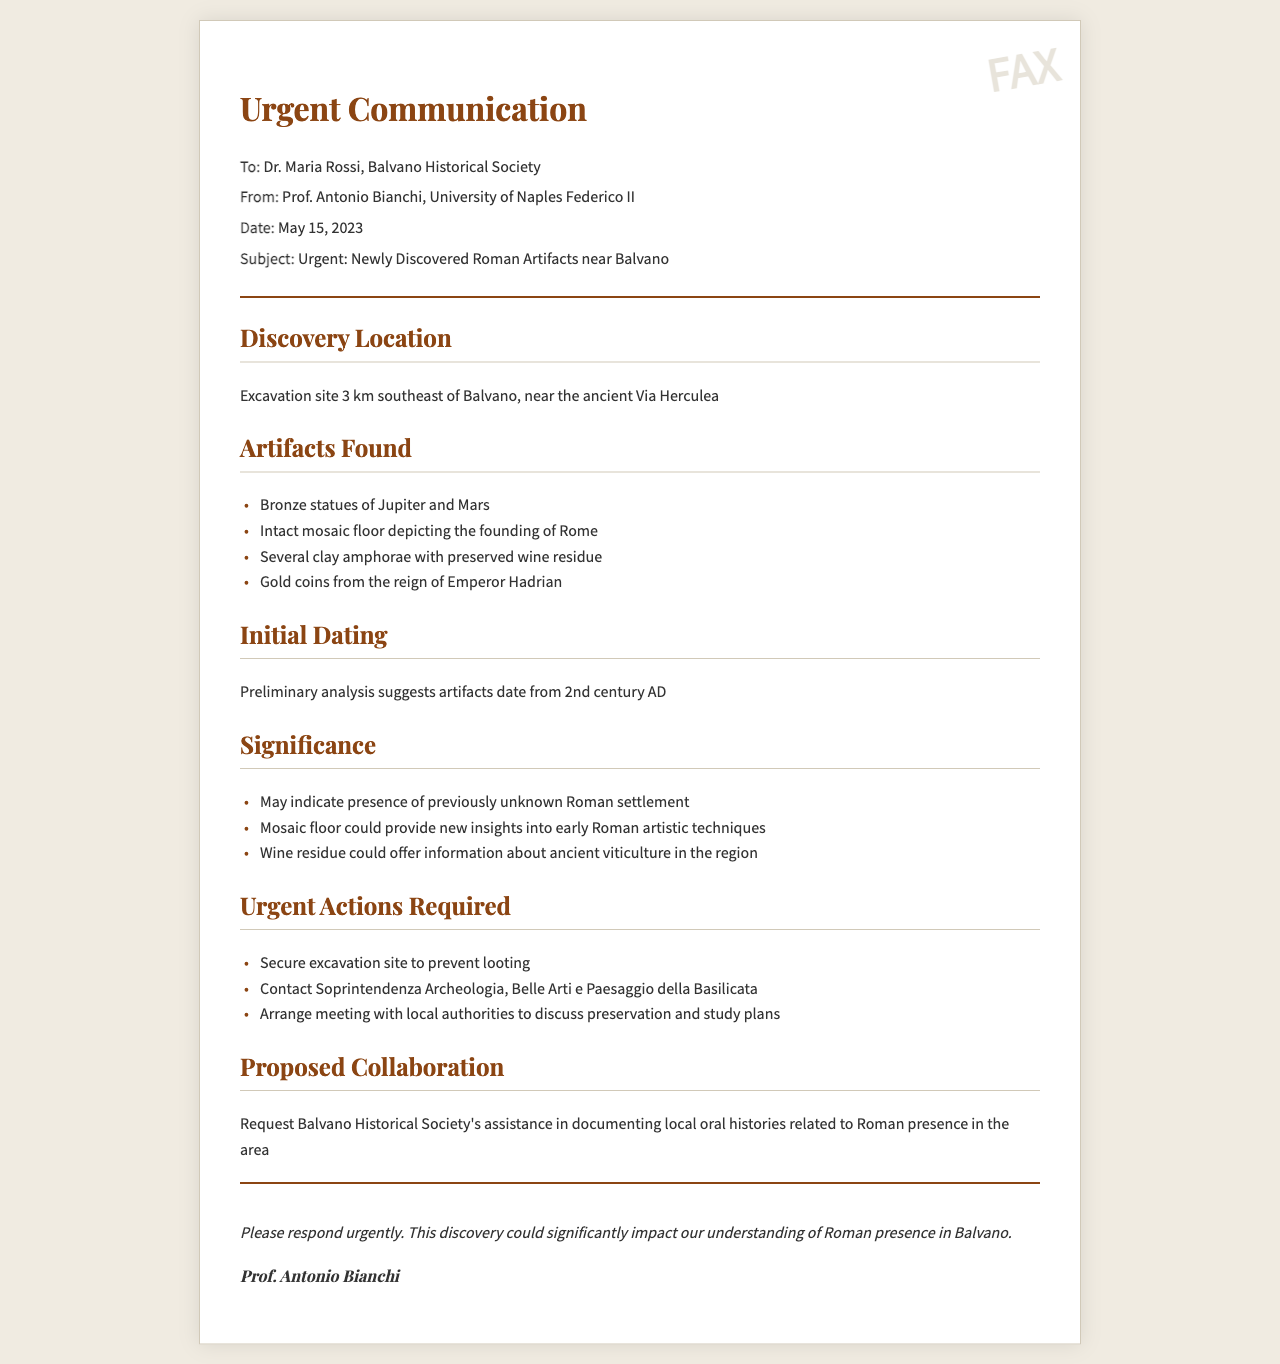What is the date of the communication? The communication is dated May 15, 2023, as mentioned in the header section of the document.
Answer: May 15, 2023 Who is the sender of the fax? The fax is sent by Prof. Antonio Bianchi, as indicated at the top of the document.
Answer: Prof. Antonio Bianchi What is one of the artifacts found near Balvano? The document lists several artifacts, one of which is the bronze statue of Jupiter.
Answer: Bronze statues of Jupiter and Mars What is the significance of the discovered mosaic floor? The mosaic floor could provide insights into early Roman artistic techniques, as stated in the significance section.
Answer: New insights into early Roman artistic techniques How far is the excavation site from Balvano? The excavation site is located 3 km southeast of Balvano, as stated in the discovery location section.
Answer: 3 km What actions are required urgently according to the document? The document outlines several urgent actions; one is to secure the excavation site to prevent looting.
Answer: Secure excavation site to prevent looting What time period do the artifacts date back to? The preliminary analysis suggests the artifacts date from the 2nd century AD, which is mentioned in the initial dating section.
Answer: 2nd century AD What department needs to be contacted regarding the discovery? The document specifies contacting Soprintendenza Archeologia, Belle Arti e Paesaggio della Basilicata as an urgent action.
Answer: Soprintendenza Archeologia, Belle Arti e Paesaggio della Basilicata What is the proposed collaboration request? The fax requests assistance in documenting local oral histories related to Roman presence, stated in the proposed collaboration section.
Answer: Documenting local oral histories related to Roman presence 